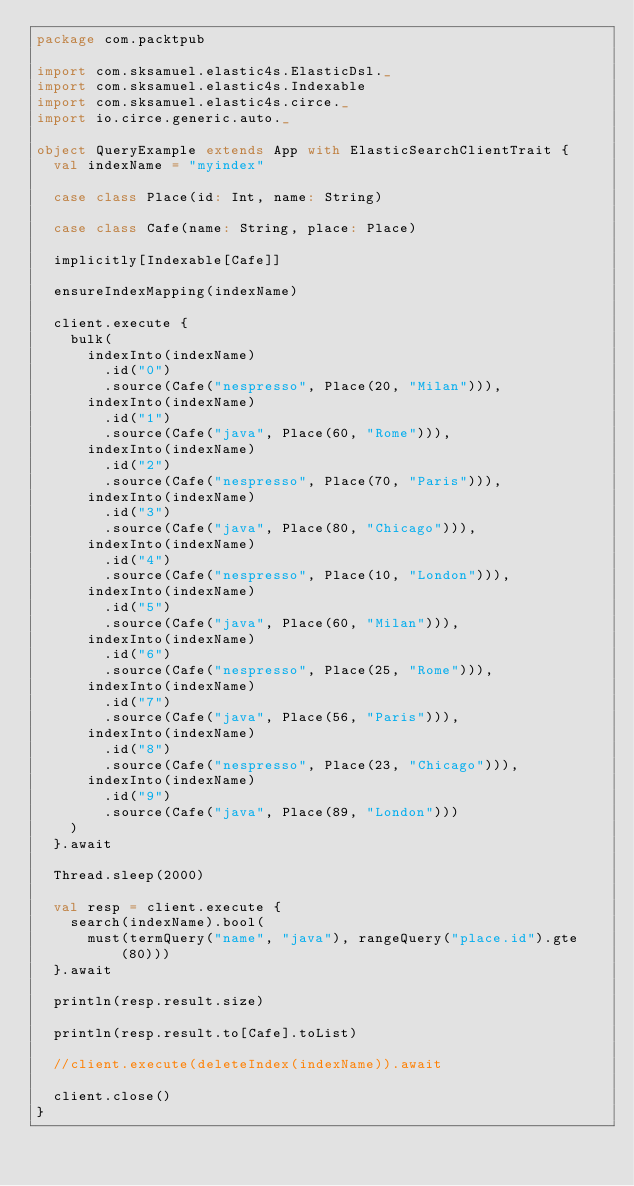<code> <loc_0><loc_0><loc_500><loc_500><_Scala_>package com.packtpub

import com.sksamuel.elastic4s.ElasticDsl._
import com.sksamuel.elastic4s.Indexable
import com.sksamuel.elastic4s.circe._
import io.circe.generic.auto._

object QueryExample extends App with ElasticSearchClientTrait {
  val indexName = "myindex"

  case class Place(id: Int, name: String)

  case class Cafe(name: String, place: Place)

  implicitly[Indexable[Cafe]]

  ensureIndexMapping(indexName)

  client.execute {
    bulk(
      indexInto(indexName)
        .id("0")
        .source(Cafe("nespresso", Place(20, "Milan"))),
      indexInto(indexName)
        .id("1")
        .source(Cafe("java", Place(60, "Rome"))),
      indexInto(indexName)
        .id("2")
        .source(Cafe("nespresso", Place(70, "Paris"))),
      indexInto(indexName)
        .id("3")
        .source(Cafe("java", Place(80, "Chicago"))),
      indexInto(indexName)
        .id("4")
        .source(Cafe("nespresso", Place(10, "London"))),
      indexInto(indexName)
        .id("5")
        .source(Cafe("java", Place(60, "Milan"))),
      indexInto(indexName)
        .id("6")
        .source(Cafe("nespresso", Place(25, "Rome"))),
      indexInto(indexName)
        .id("7")
        .source(Cafe("java", Place(56, "Paris"))),
      indexInto(indexName)
        .id("8")
        .source(Cafe("nespresso", Place(23, "Chicago"))),
      indexInto(indexName)
        .id("9")
        .source(Cafe("java", Place(89, "London")))
    )
  }.await

  Thread.sleep(2000)

  val resp = client.execute {
    search(indexName).bool(
      must(termQuery("name", "java"), rangeQuery("place.id").gte(80)))
  }.await

  println(resp.result.size)

  println(resp.result.to[Cafe].toList)

  //client.execute(deleteIndex(indexName)).await

  client.close()
}
</code> 